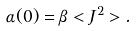<formula> <loc_0><loc_0><loc_500><loc_500>\alpha ( 0 ) = \beta < J ^ { 2 } > .</formula> 